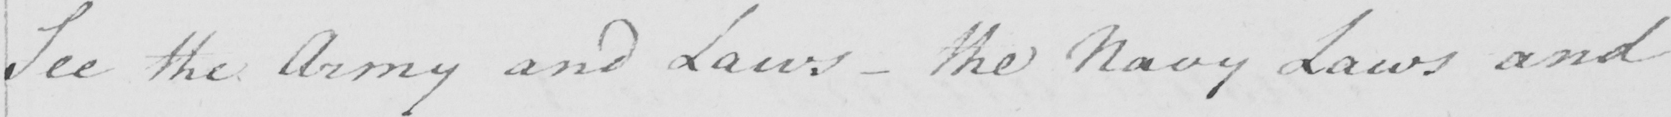What is written in this line of handwriting? See the Army and Laws  _  the Navy Laws and 